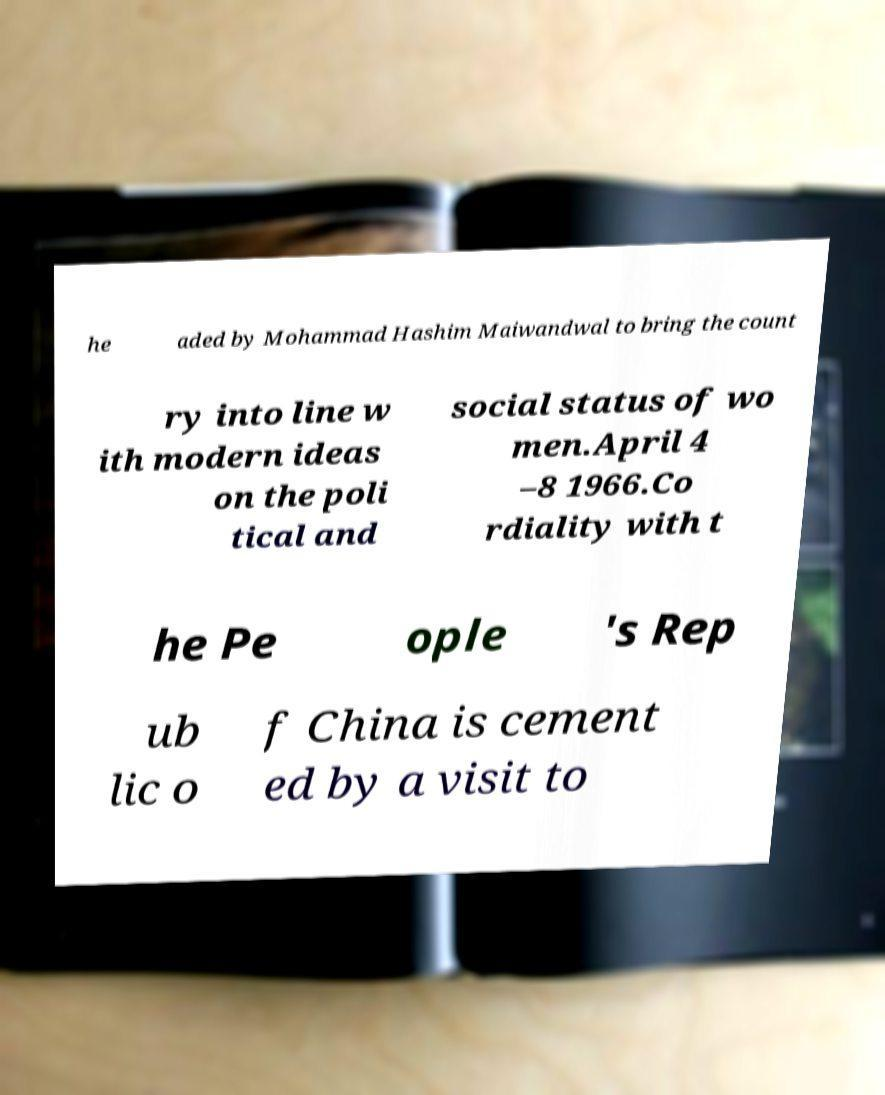Could you assist in decoding the text presented in this image and type it out clearly? he aded by Mohammad Hashim Maiwandwal to bring the count ry into line w ith modern ideas on the poli tical and social status of wo men.April 4 –8 1966.Co rdiality with t he Pe ople 's Rep ub lic o f China is cement ed by a visit to 